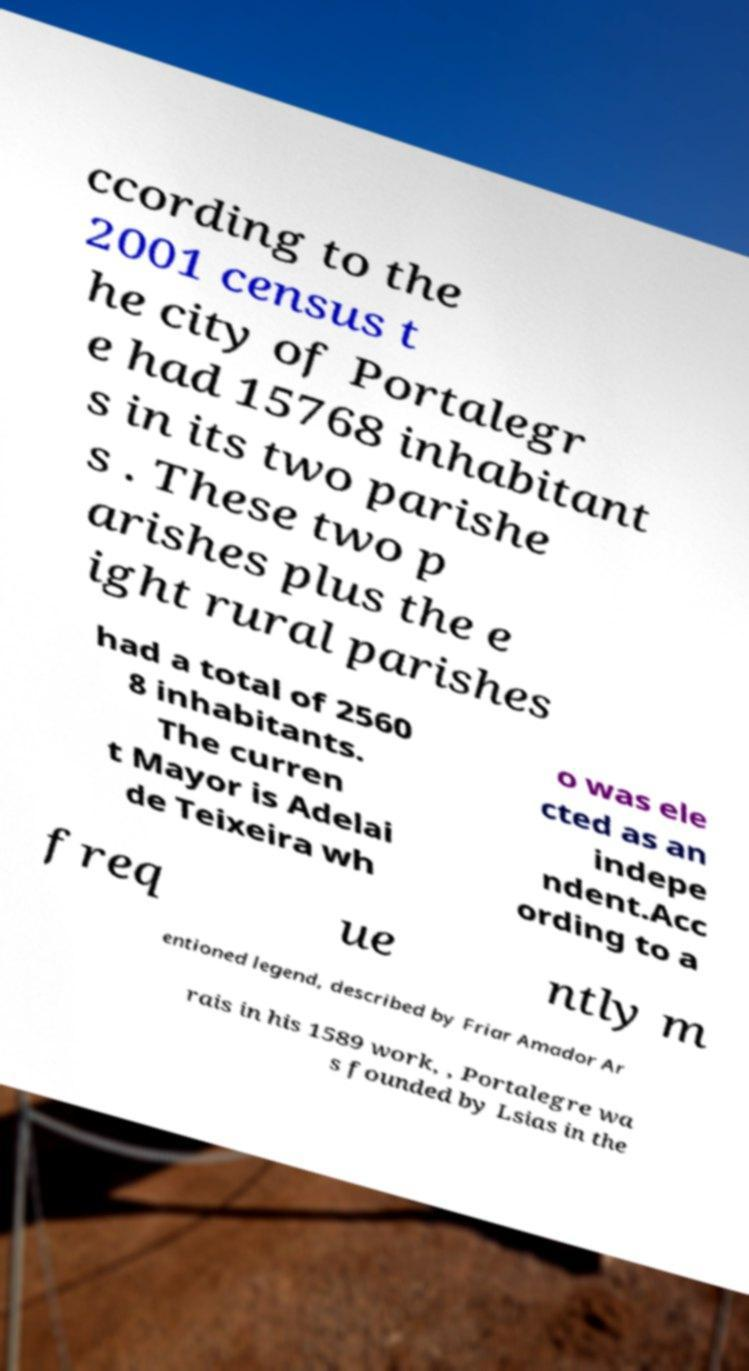Please read and relay the text visible in this image. What does it say? ccording to the 2001 census t he city of Portalegr e had 15768 inhabitant s in its two parishe s . These two p arishes plus the e ight rural parishes had a total of 2560 8 inhabitants. The curren t Mayor is Adelai de Teixeira wh o was ele cted as an indepe ndent.Acc ording to a freq ue ntly m entioned legend, described by Friar Amador Ar rais in his 1589 work, , Portalegre wa s founded by Lsias in the 